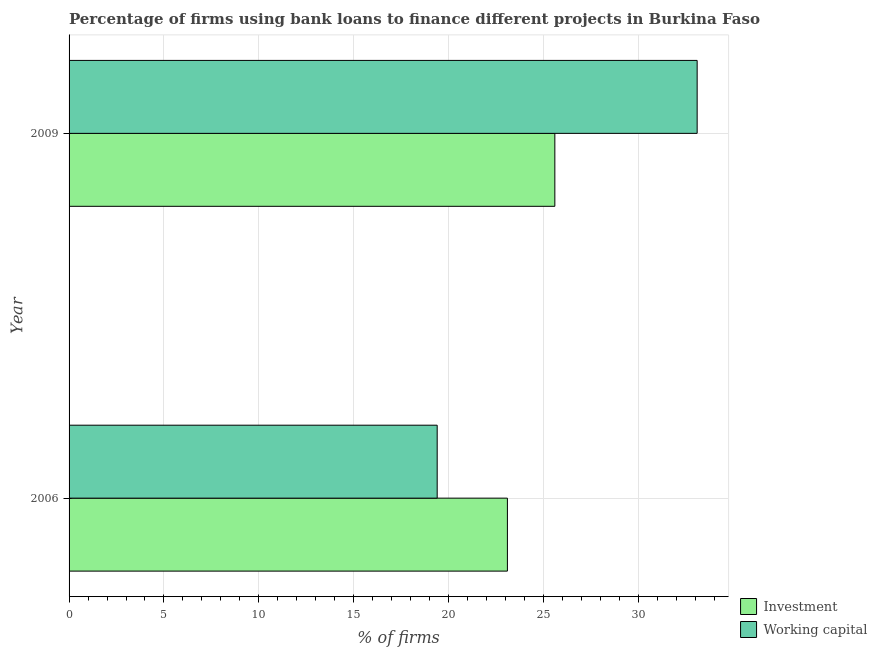Are the number of bars on each tick of the Y-axis equal?
Offer a terse response. Yes. What is the label of the 2nd group of bars from the top?
Your response must be concise. 2006. What is the percentage of firms using banks to finance investment in 2006?
Make the answer very short. 23.1. Across all years, what is the maximum percentage of firms using banks to finance investment?
Offer a very short reply. 25.6. In which year was the percentage of firms using banks to finance investment minimum?
Offer a terse response. 2006. What is the total percentage of firms using banks to finance investment in the graph?
Keep it short and to the point. 48.7. What is the difference between the percentage of firms using banks to finance working capital in 2006 and that in 2009?
Your response must be concise. -13.7. What is the average percentage of firms using banks to finance investment per year?
Make the answer very short. 24.35. In the year 2006, what is the difference between the percentage of firms using banks to finance working capital and percentage of firms using banks to finance investment?
Make the answer very short. -3.7. In how many years, is the percentage of firms using banks to finance working capital greater than 4 %?
Make the answer very short. 2. What is the ratio of the percentage of firms using banks to finance investment in 2006 to that in 2009?
Provide a short and direct response. 0.9. What does the 1st bar from the top in 2009 represents?
Your answer should be very brief. Working capital. What does the 1st bar from the bottom in 2006 represents?
Offer a very short reply. Investment. What is the difference between two consecutive major ticks on the X-axis?
Your response must be concise. 5. How many legend labels are there?
Provide a succinct answer. 2. How are the legend labels stacked?
Provide a short and direct response. Vertical. What is the title of the graph?
Provide a short and direct response. Percentage of firms using bank loans to finance different projects in Burkina Faso. What is the label or title of the X-axis?
Your answer should be very brief. % of firms. What is the label or title of the Y-axis?
Your response must be concise. Year. What is the % of firms in Investment in 2006?
Your answer should be compact. 23.1. What is the % of firms of Investment in 2009?
Provide a short and direct response. 25.6. What is the % of firms in Working capital in 2009?
Your answer should be very brief. 33.1. Across all years, what is the maximum % of firms in Investment?
Your answer should be compact. 25.6. Across all years, what is the maximum % of firms of Working capital?
Your answer should be very brief. 33.1. Across all years, what is the minimum % of firms in Investment?
Offer a terse response. 23.1. Across all years, what is the minimum % of firms of Working capital?
Your response must be concise. 19.4. What is the total % of firms in Investment in the graph?
Your answer should be compact. 48.7. What is the total % of firms in Working capital in the graph?
Make the answer very short. 52.5. What is the difference between the % of firms of Investment in 2006 and that in 2009?
Keep it short and to the point. -2.5. What is the difference between the % of firms of Working capital in 2006 and that in 2009?
Keep it short and to the point. -13.7. What is the difference between the % of firms of Investment in 2006 and the % of firms of Working capital in 2009?
Keep it short and to the point. -10. What is the average % of firms of Investment per year?
Keep it short and to the point. 24.35. What is the average % of firms of Working capital per year?
Keep it short and to the point. 26.25. In the year 2006, what is the difference between the % of firms of Investment and % of firms of Working capital?
Your response must be concise. 3.7. In the year 2009, what is the difference between the % of firms of Investment and % of firms of Working capital?
Provide a succinct answer. -7.5. What is the ratio of the % of firms in Investment in 2006 to that in 2009?
Give a very brief answer. 0.9. What is the ratio of the % of firms in Working capital in 2006 to that in 2009?
Ensure brevity in your answer.  0.59. What is the difference between the highest and the second highest % of firms in Working capital?
Your answer should be very brief. 13.7. 